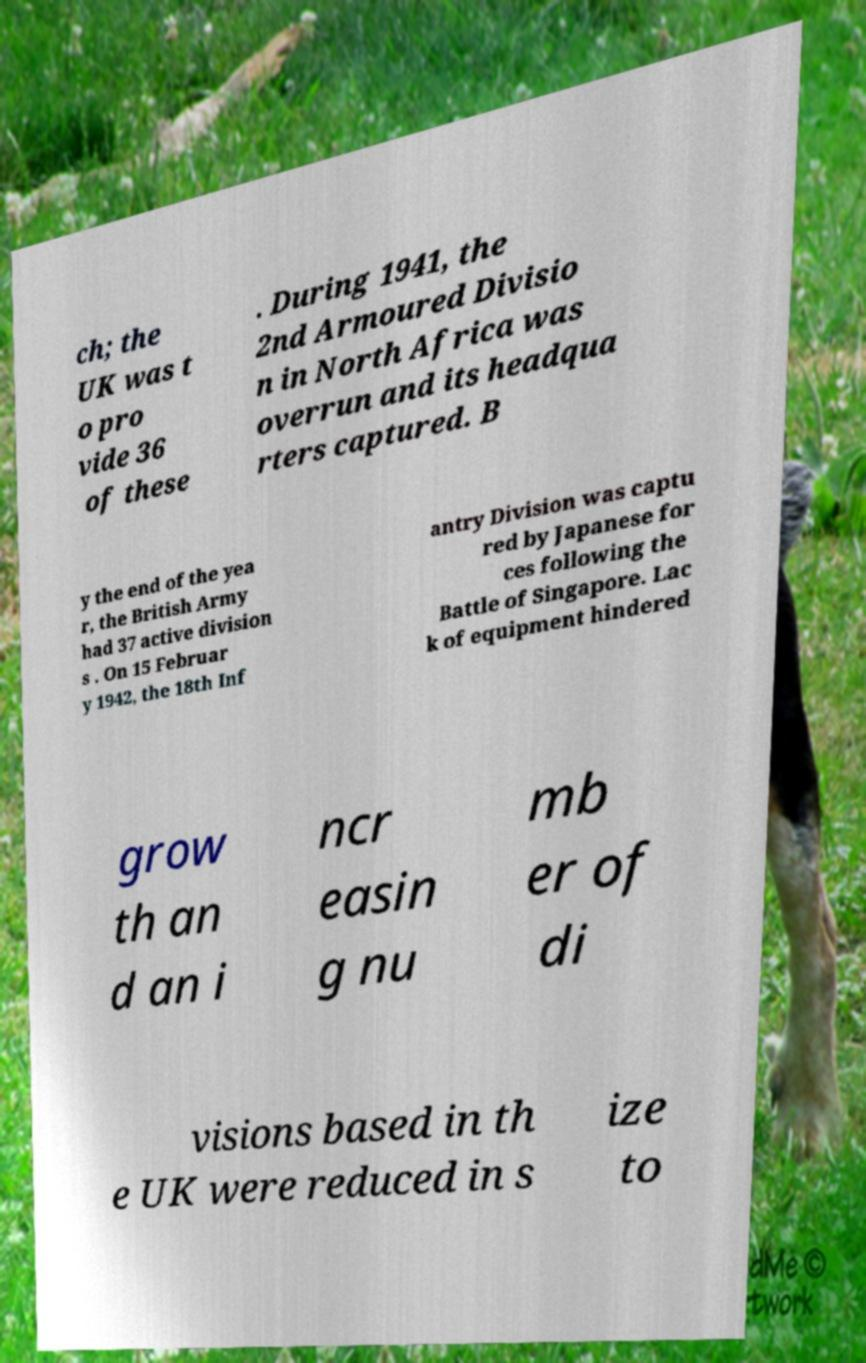Could you extract and type out the text from this image? ch; the UK was t o pro vide 36 of these . During 1941, the 2nd Armoured Divisio n in North Africa was overrun and its headqua rters captured. B y the end of the yea r, the British Army had 37 active division s . On 15 Februar y 1942, the 18th Inf antry Division was captu red by Japanese for ces following the Battle of Singapore. Lac k of equipment hindered grow th an d an i ncr easin g nu mb er of di visions based in th e UK were reduced in s ize to 